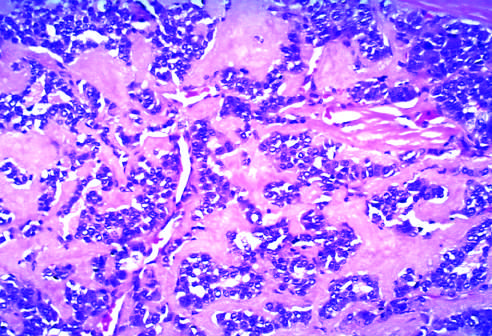s the polyp derived from calcitonin molecules secreted by the neoplastic cells?
Answer the question using a single word or phrase. No 